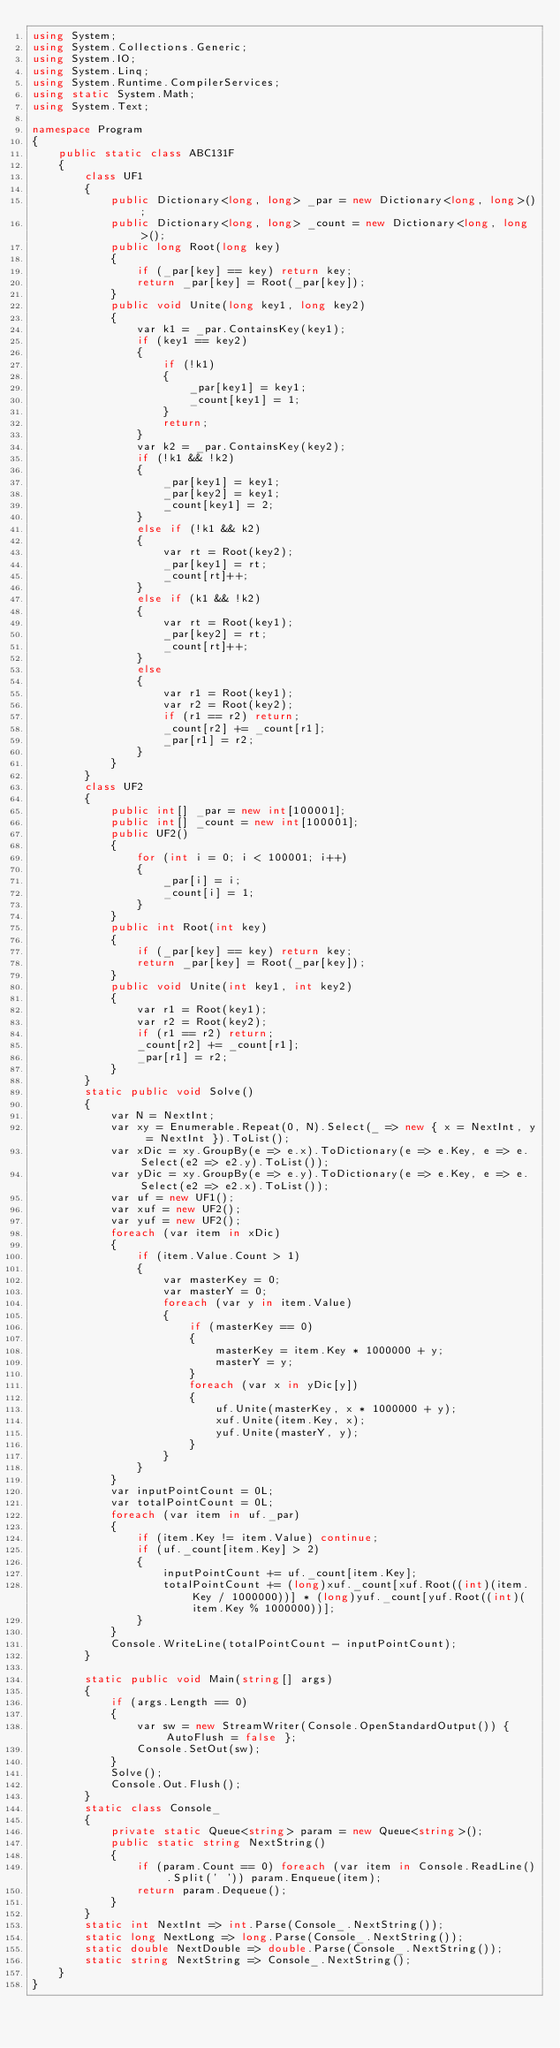Convert code to text. <code><loc_0><loc_0><loc_500><loc_500><_C#_>using System;
using System.Collections.Generic;
using System.IO;
using System.Linq;
using System.Runtime.CompilerServices;
using static System.Math;
using System.Text;

namespace Program
{
    public static class ABC131F
    {
        class UF1
        {
            public Dictionary<long, long> _par = new Dictionary<long, long>();
            public Dictionary<long, long> _count = new Dictionary<long, long>();
            public long Root(long key)
            {
                if (_par[key] == key) return key;
                return _par[key] = Root(_par[key]);
            }
            public void Unite(long key1, long key2)
            {
                var k1 = _par.ContainsKey(key1);
                if (key1 == key2)
                {
                    if (!k1)
                    {
                        _par[key1] = key1;
                        _count[key1] = 1;
                    }
                    return;
                }
                var k2 = _par.ContainsKey(key2);
                if (!k1 && !k2)
                {
                    _par[key1] = key1;
                    _par[key2] = key1;
                    _count[key1] = 2;
                }
                else if (!k1 && k2)
                {
                    var rt = Root(key2);
                    _par[key1] = rt;
                    _count[rt]++;
                }
                else if (k1 && !k2)
                {
                    var rt = Root(key1);
                    _par[key2] = rt;
                    _count[rt]++;
                }
                else
                {
                    var r1 = Root(key1);
                    var r2 = Root(key2);
                    if (r1 == r2) return;
                    _count[r2] += _count[r1];
                    _par[r1] = r2;
                }
            }
        }
        class UF2
        {
            public int[] _par = new int[100001];
            public int[] _count = new int[100001];
            public UF2()
            {
                for (int i = 0; i < 100001; i++)
                {
                    _par[i] = i;
                    _count[i] = 1;
                }
            }
            public int Root(int key)
            {
                if (_par[key] == key) return key;
                return _par[key] = Root(_par[key]);
            }
            public void Unite(int key1, int key2)
            {
                var r1 = Root(key1);
                var r2 = Root(key2);
                if (r1 == r2) return;
                _count[r2] += _count[r1];
                _par[r1] = r2;
            }
        }
        static public void Solve()
        {
            var N = NextInt;
            var xy = Enumerable.Repeat(0, N).Select(_ => new { x = NextInt, y = NextInt }).ToList();
            var xDic = xy.GroupBy(e => e.x).ToDictionary(e => e.Key, e => e.Select(e2 => e2.y).ToList());
            var yDic = xy.GroupBy(e => e.y).ToDictionary(e => e.Key, e => e.Select(e2 => e2.x).ToList());
            var uf = new UF1();
            var xuf = new UF2();
            var yuf = new UF2();
            foreach (var item in xDic)
            {
                if (item.Value.Count > 1)
                {
                    var masterKey = 0;
                    var masterY = 0;
                    foreach (var y in item.Value)
                    {
                        if (masterKey == 0)
                        {
                            masterKey = item.Key * 1000000 + y;
                            masterY = y;
                        }
                        foreach (var x in yDic[y])
                        {
                            uf.Unite(masterKey, x * 1000000 + y);
                            xuf.Unite(item.Key, x);
                            yuf.Unite(masterY, y);
                        }
                    }
                }
            }
            var inputPointCount = 0L;
            var totalPointCount = 0L;
            foreach (var item in uf._par)
            {
                if (item.Key != item.Value) continue;
                if (uf._count[item.Key] > 2)
                {
                    inputPointCount += uf._count[item.Key];
                    totalPointCount += (long)xuf._count[xuf.Root((int)(item.Key / 1000000))] * (long)yuf._count[yuf.Root((int)(item.Key % 1000000))];
                }
            }
            Console.WriteLine(totalPointCount - inputPointCount);
        }

        static public void Main(string[] args)
        {
            if (args.Length == 0)
            {
                var sw = new StreamWriter(Console.OpenStandardOutput()) { AutoFlush = false };
                Console.SetOut(sw);
            }
            Solve();
            Console.Out.Flush();
        }
        static class Console_
        {
            private static Queue<string> param = new Queue<string>();
            public static string NextString()
            {
                if (param.Count == 0) foreach (var item in Console.ReadLine().Split(' ')) param.Enqueue(item);
                return param.Dequeue();
            }
        }
        static int NextInt => int.Parse(Console_.NextString());
        static long NextLong => long.Parse(Console_.NextString());
        static double NextDouble => double.Parse(Console_.NextString());
        static string NextString => Console_.NextString();
    }
}
</code> 